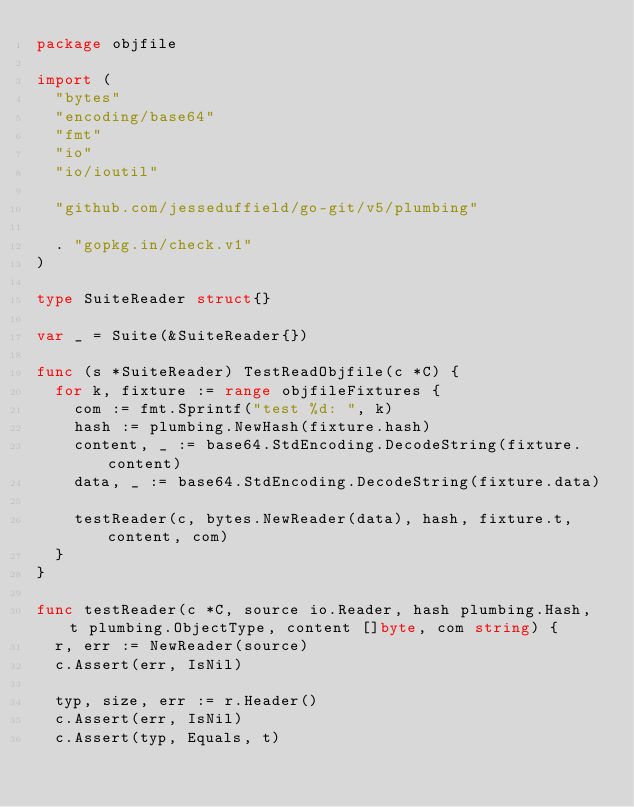Convert code to text. <code><loc_0><loc_0><loc_500><loc_500><_Go_>package objfile

import (
	"bytes"
	"encoding/base64"
	"fmt"
	"io"
	"io/ioutil"

	"github.com/jesseduffield/go-git/v5/plumbing"

	. "gopkg.in/check.v1"
)

type SuiteReader struct{}

var _ = Suite(&SuiteReader{})

func (s *SuiteReader) TestReadObjfile(c *C) {
	for k, fixture := range objfileFixtures {
		com := fmt.Sprintf("test %d: ", k)
		hash := plumbing.NewHash(fixture.hash)
		content, _ := base64.StdEncoding.DecodeString(fixture.content)
		data, _ := base64.StdEncoding.DecodeString(fixture.data)

		testReader(c, bytes.NewReader(data), hash, fixture.t, content, com)
	}
}

func testReader(c *C, source io.Reader, hash plumbing.Hash, t plumbing.ObjectType, content []byte, com string) {
	r, err := NewReader(source)
	c.Assert(err, IsNil)

	typ, size, err := r.Header()
	c.Assert(err, IsNil)
	c.Assert(typ, Equals, t)</code> 